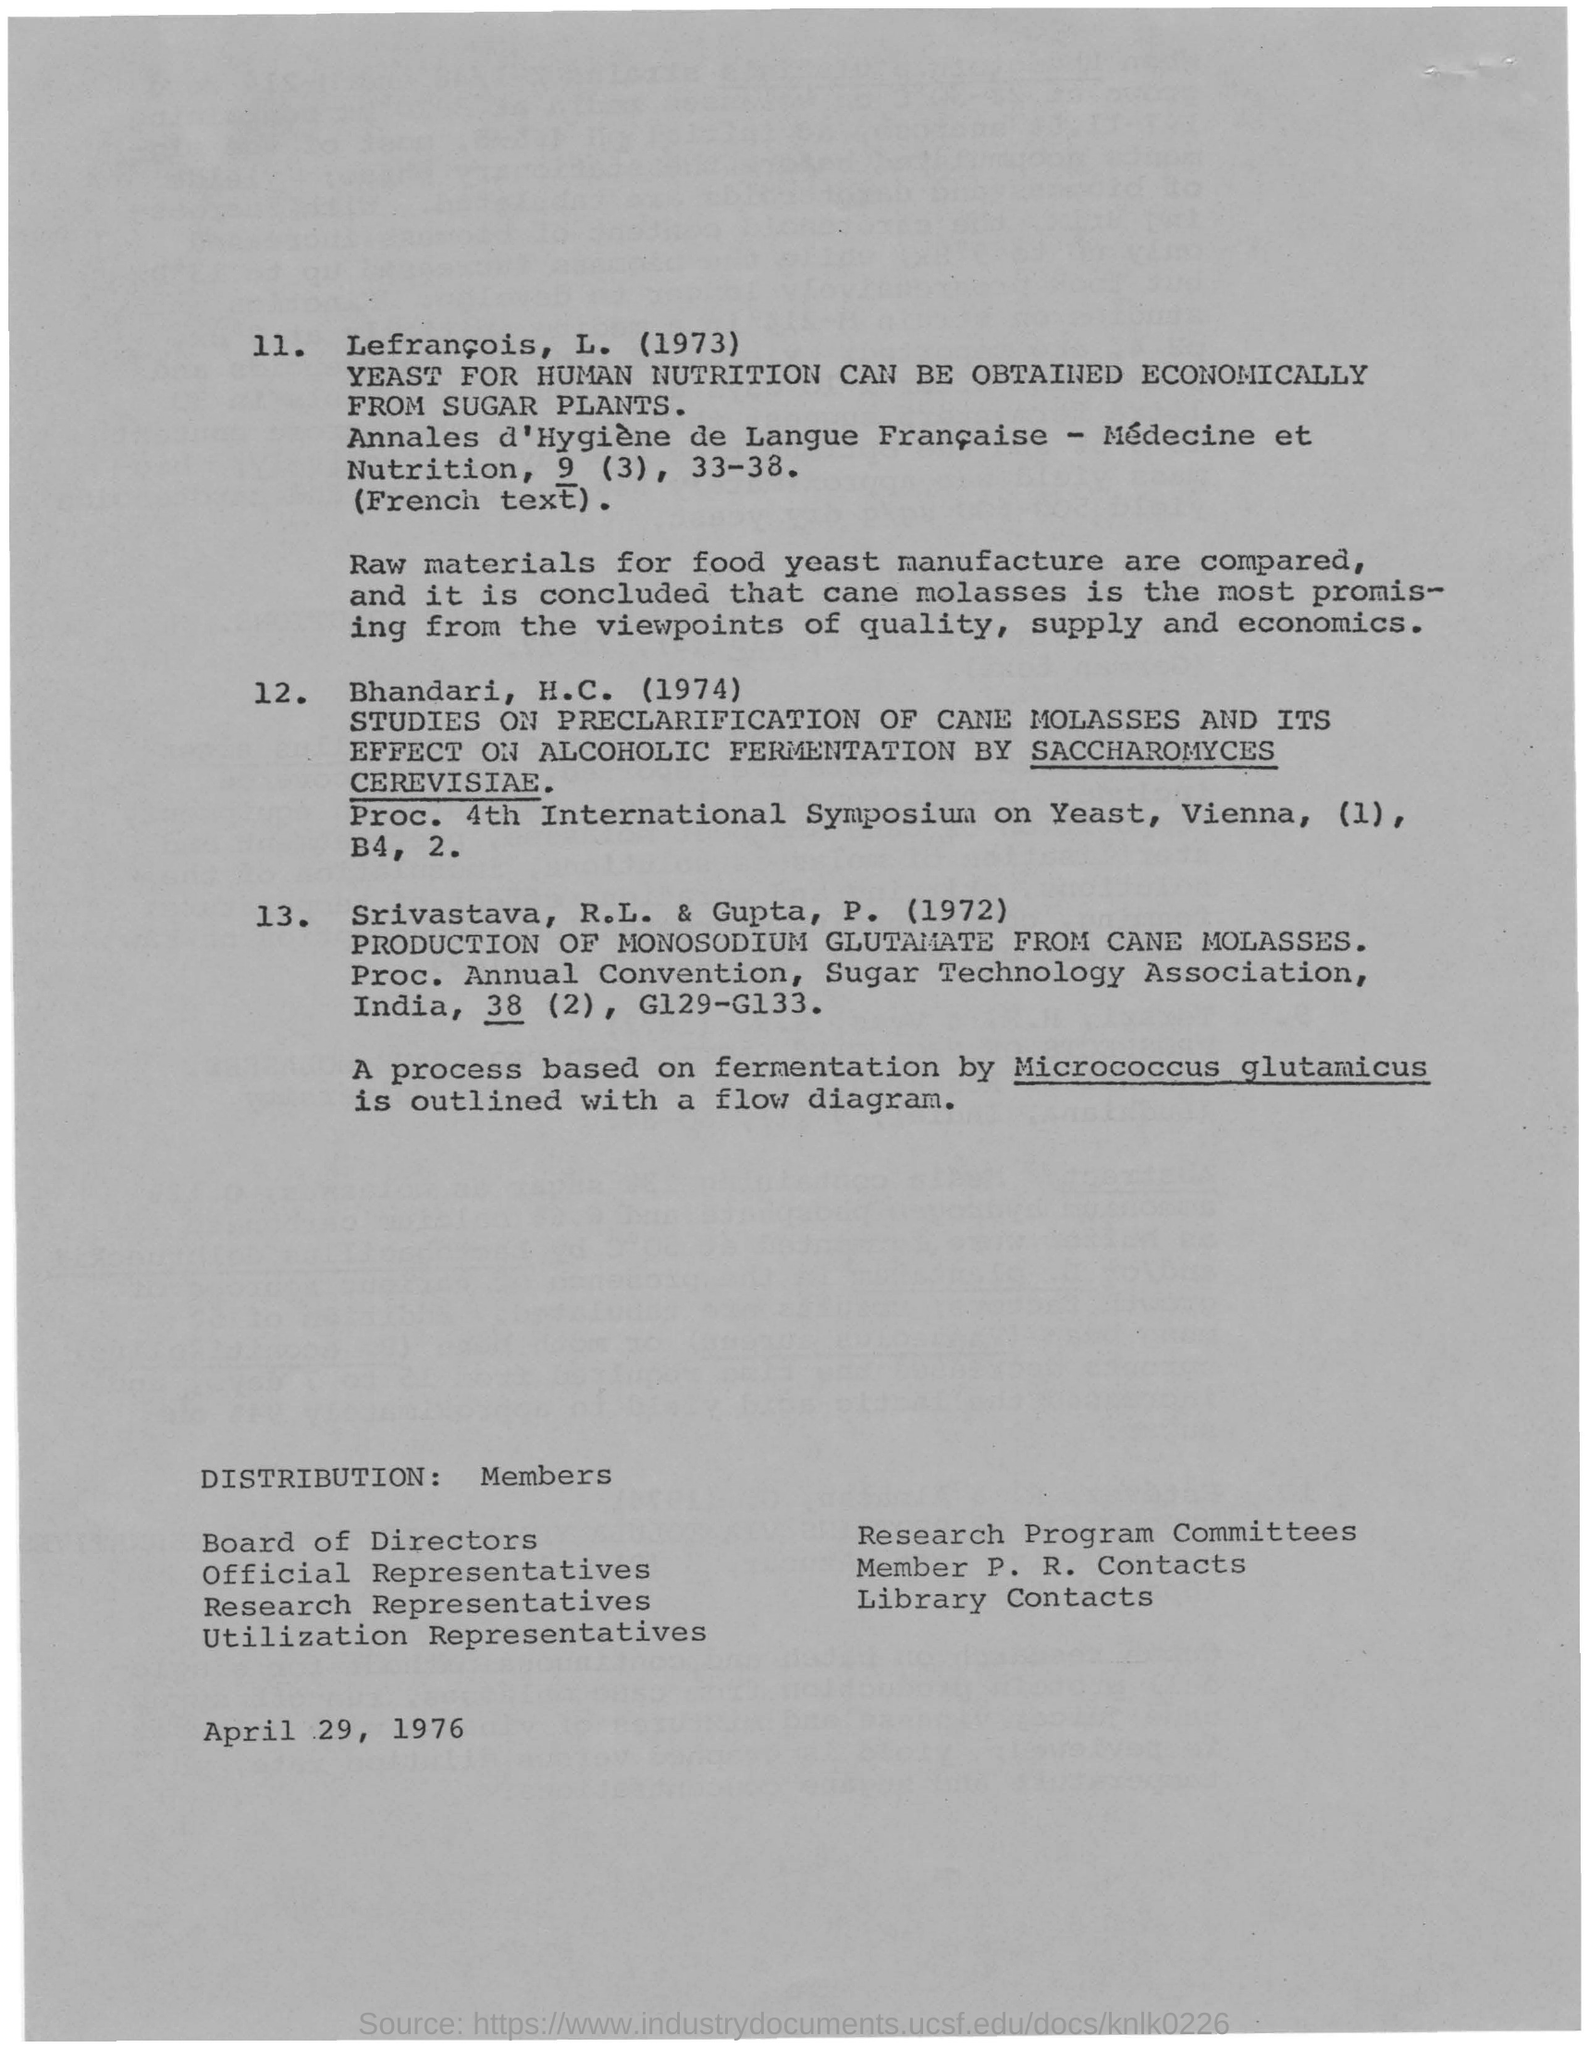Outline some significant characteristics in this image. Yeast obtained from sugar plants is an economical source of nutrition for humans. Cane molasses is the most promising raw material from the viewpoints of quality, supply, and economics. A process for fermentation using Micrococcus glutamicus outlined in a flow diagram has been successfully implemented. 